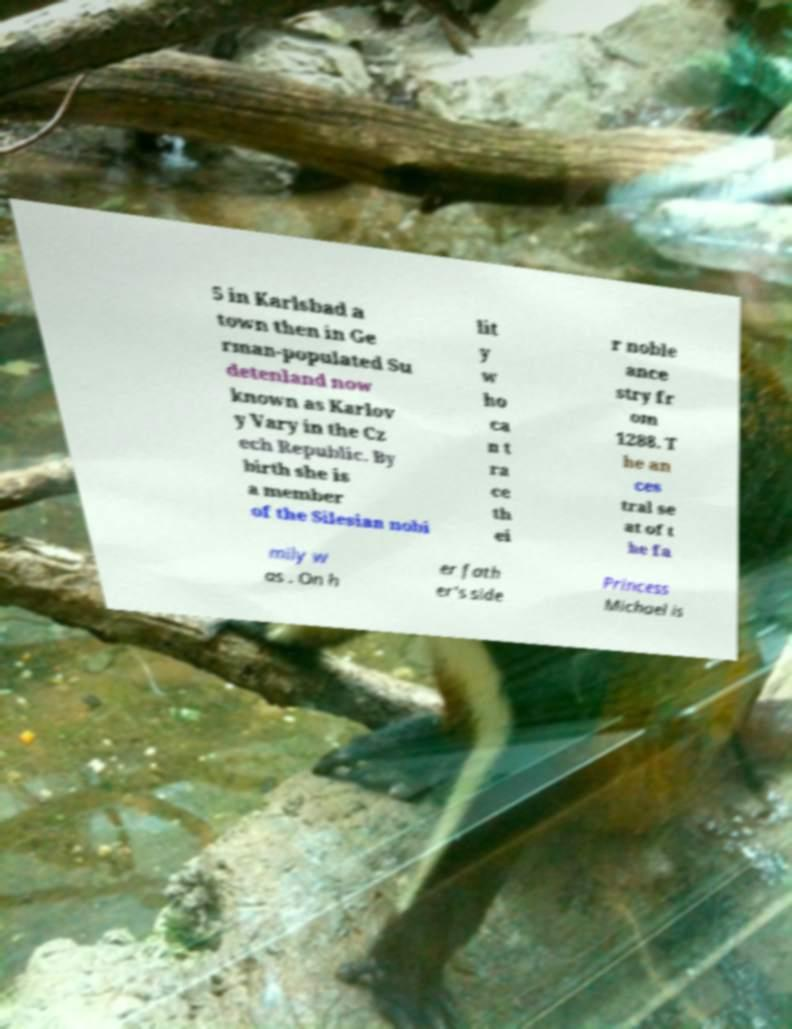There's text embedded in this image that I need extracted. Can you transcribe it verbatim? 5 in Karlsbad a town then in Ge rman-populated Su detenland now known as Karlov y Vary in the Cz ech Republic. By birth she is a member of the Silesian nobi lit y w ho ca n t ra ce th ei r noble ance stry fr om 1288. T he an ces tral se at of t he fa mily w as . On h er fath er's side Princess Michael is 